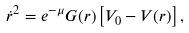<formula> <loc_0><loc_0><loc_500><loc_500>\dot { r } ^ { 2 } = e ^ { - \mu } G ( r ) \left [ V _ { 0 } - V ( r ) \right ] ,</formula> 